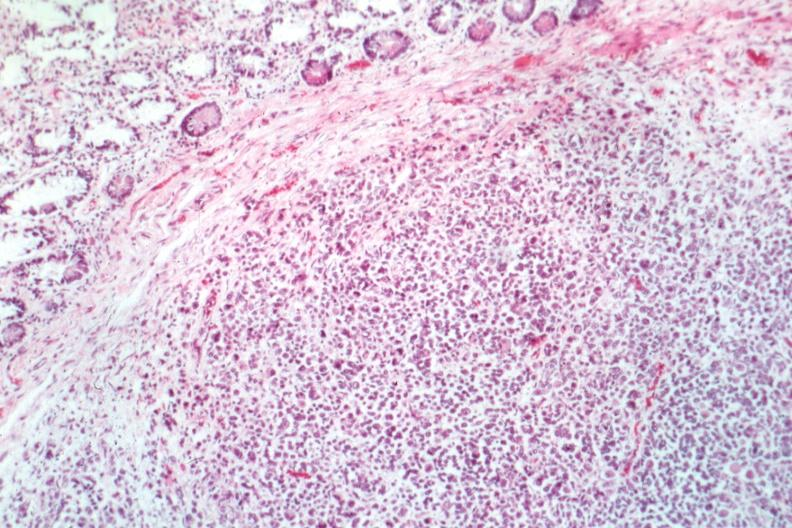s esophagus?
Answer the question using a single word or phrase. No 